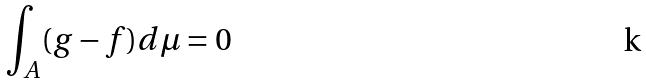<formula> <loc_0><loc_0><loc_500><loc_500>\int _ { A } ( g - f ) d \mu = 0</formula> 